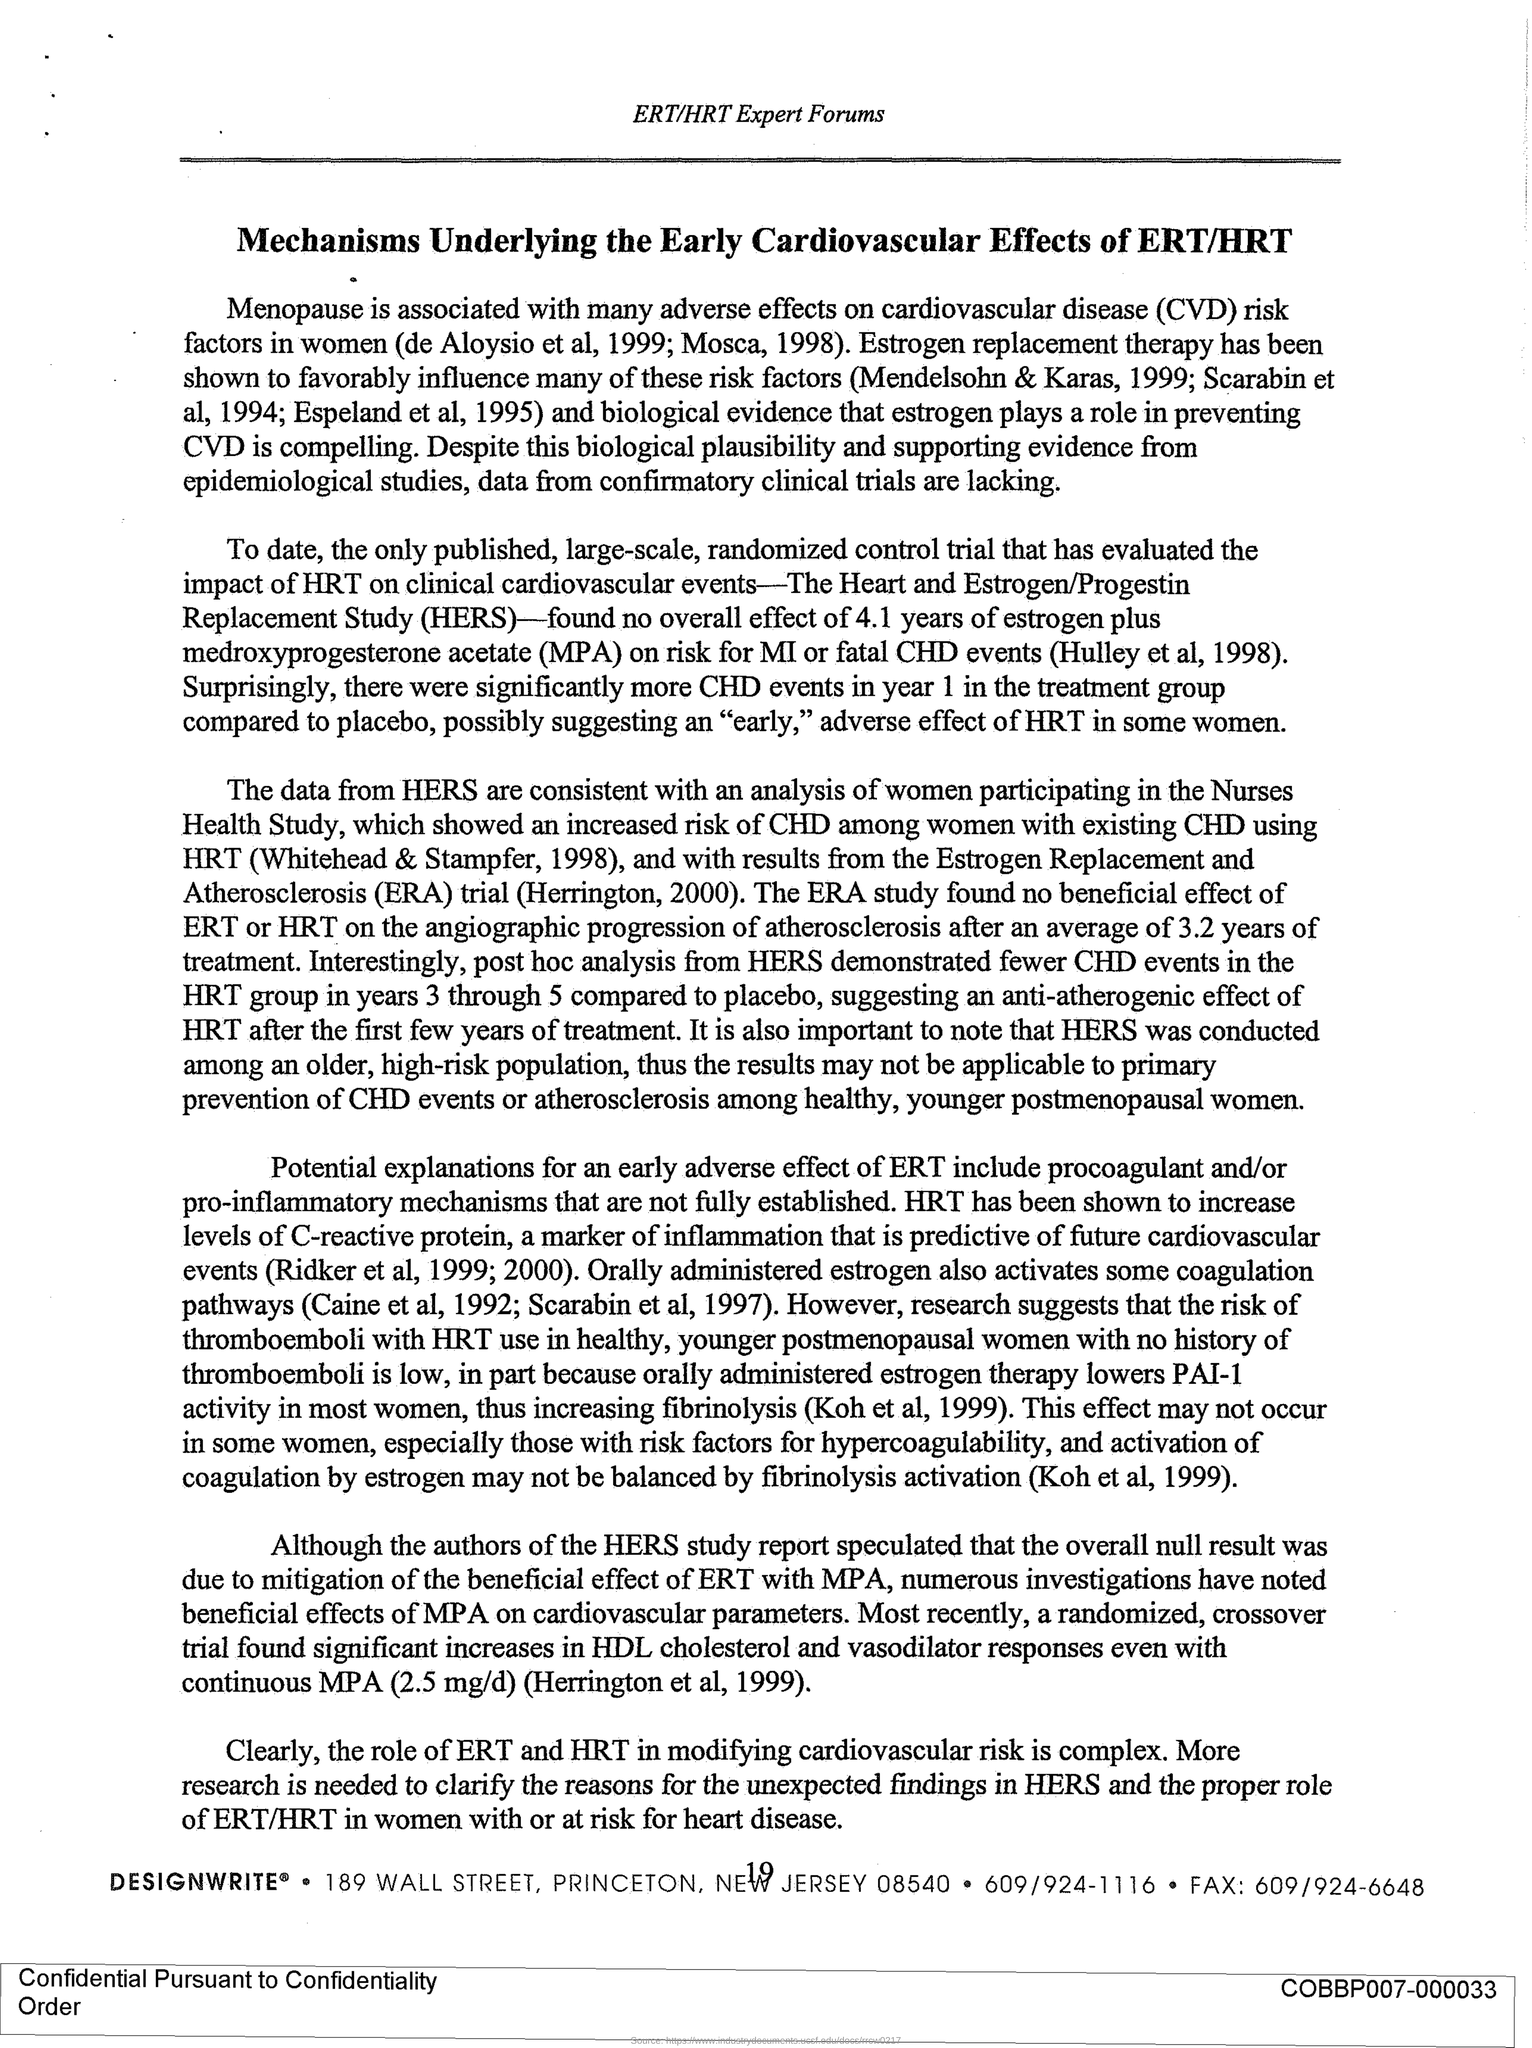Point out several critical features in this image. Cardiovascular Disease (CVD) is a term used to describe a range of conditions that affect the heart and blood vessels. The title of this document is "Mechanisms Underlying the Early Cardiovascular Effects of Estrogen Receptor Triple-Negative Breast Cancer Therapy/Hormone Replacement Therapy. The abbreviation for 'The Heart and Estrogen/Progestin Replacement Study' is HERS. The header of the document mentions the ERT/HRT Expert Forums forum. 